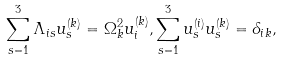Convert formula to latex. <formula><loc_0><loc_0><loc_500><loc_500>\sum _ { s = 1 } ^ { 3 } \Lambda _ { i s } u _ { s } ^ { ( k ) } = \Omega _ { k } ^ { 2 } u _ { i } ^ { ( k ) } , \sum _ { s = 1 } ^ { 3 } u _ { s } ^ { ( i ) } u _ { s } ^ { ( k ) } = \delta _ { i k } ,</formula> 